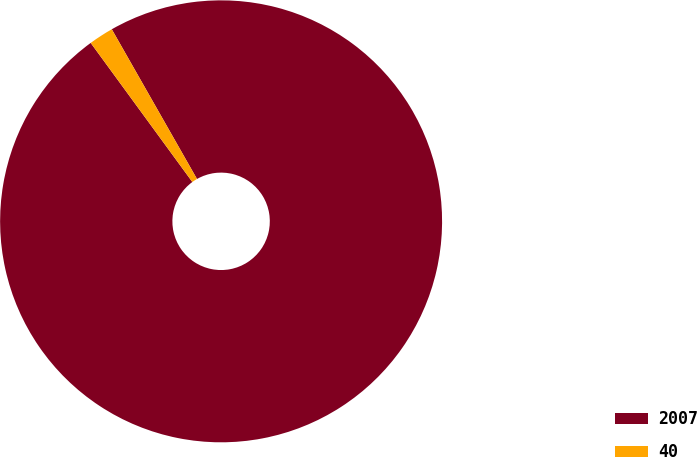Convert chart. <chart><loc_0><loc_0><loc_500><loc_500><pie_chart><fcel>2007<fcel>40<nl><fcel>98.19%<fcel>1.81%<nl></chart> 